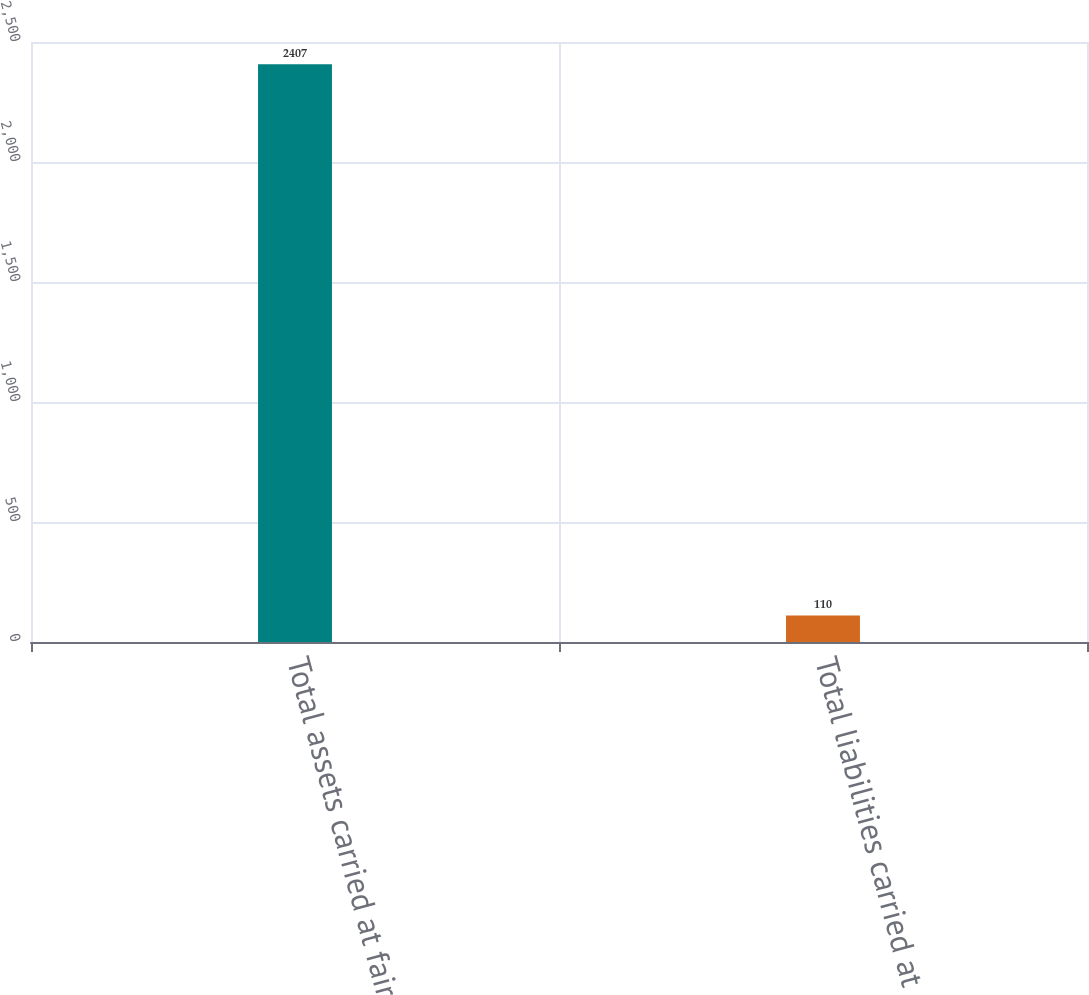Convert chart to OTSL. <chart><loc_0><loc_0><loc_500><loc_500><bar_chart><fcel>Total assets carried at fair<fcel>Total liabilities carried at<nl><fcel>2407<fcel>110<nl></chart> 